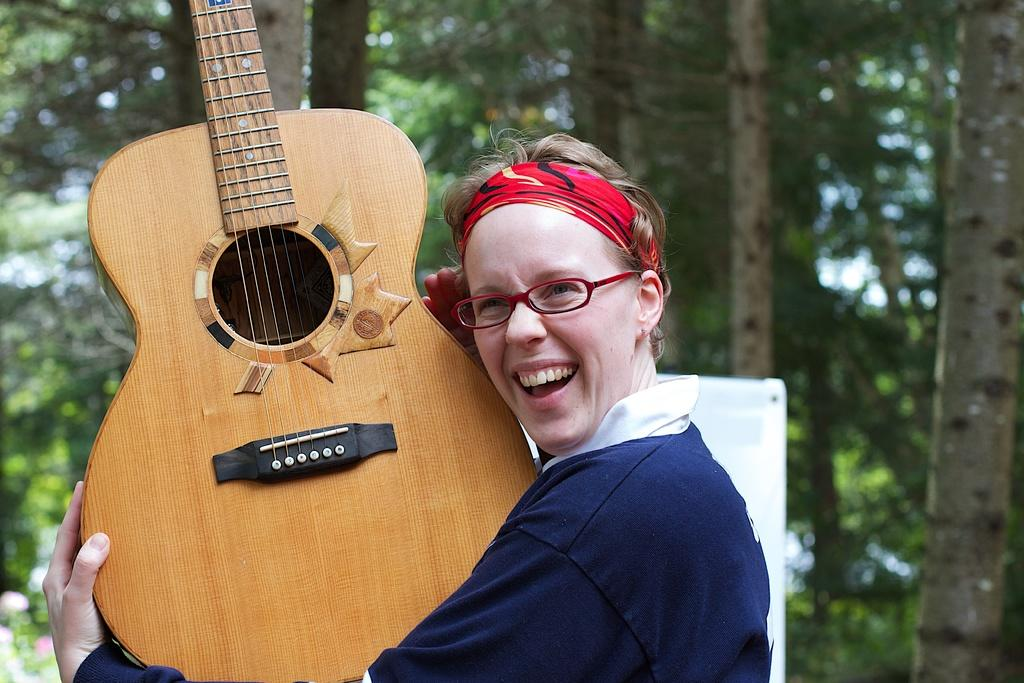What is the person in the image doing? The person is holding a guitar. What is the person's facial expression in the image? The person is smiling. What can be seen in the background of the image? There are trees in the background of the image. What type of vein is visible on the person's arm in the image? There is no visible vein on the person's arm in the image. What type of cabbage is being used as a prop in the image? There is no cabbage present in the image. 